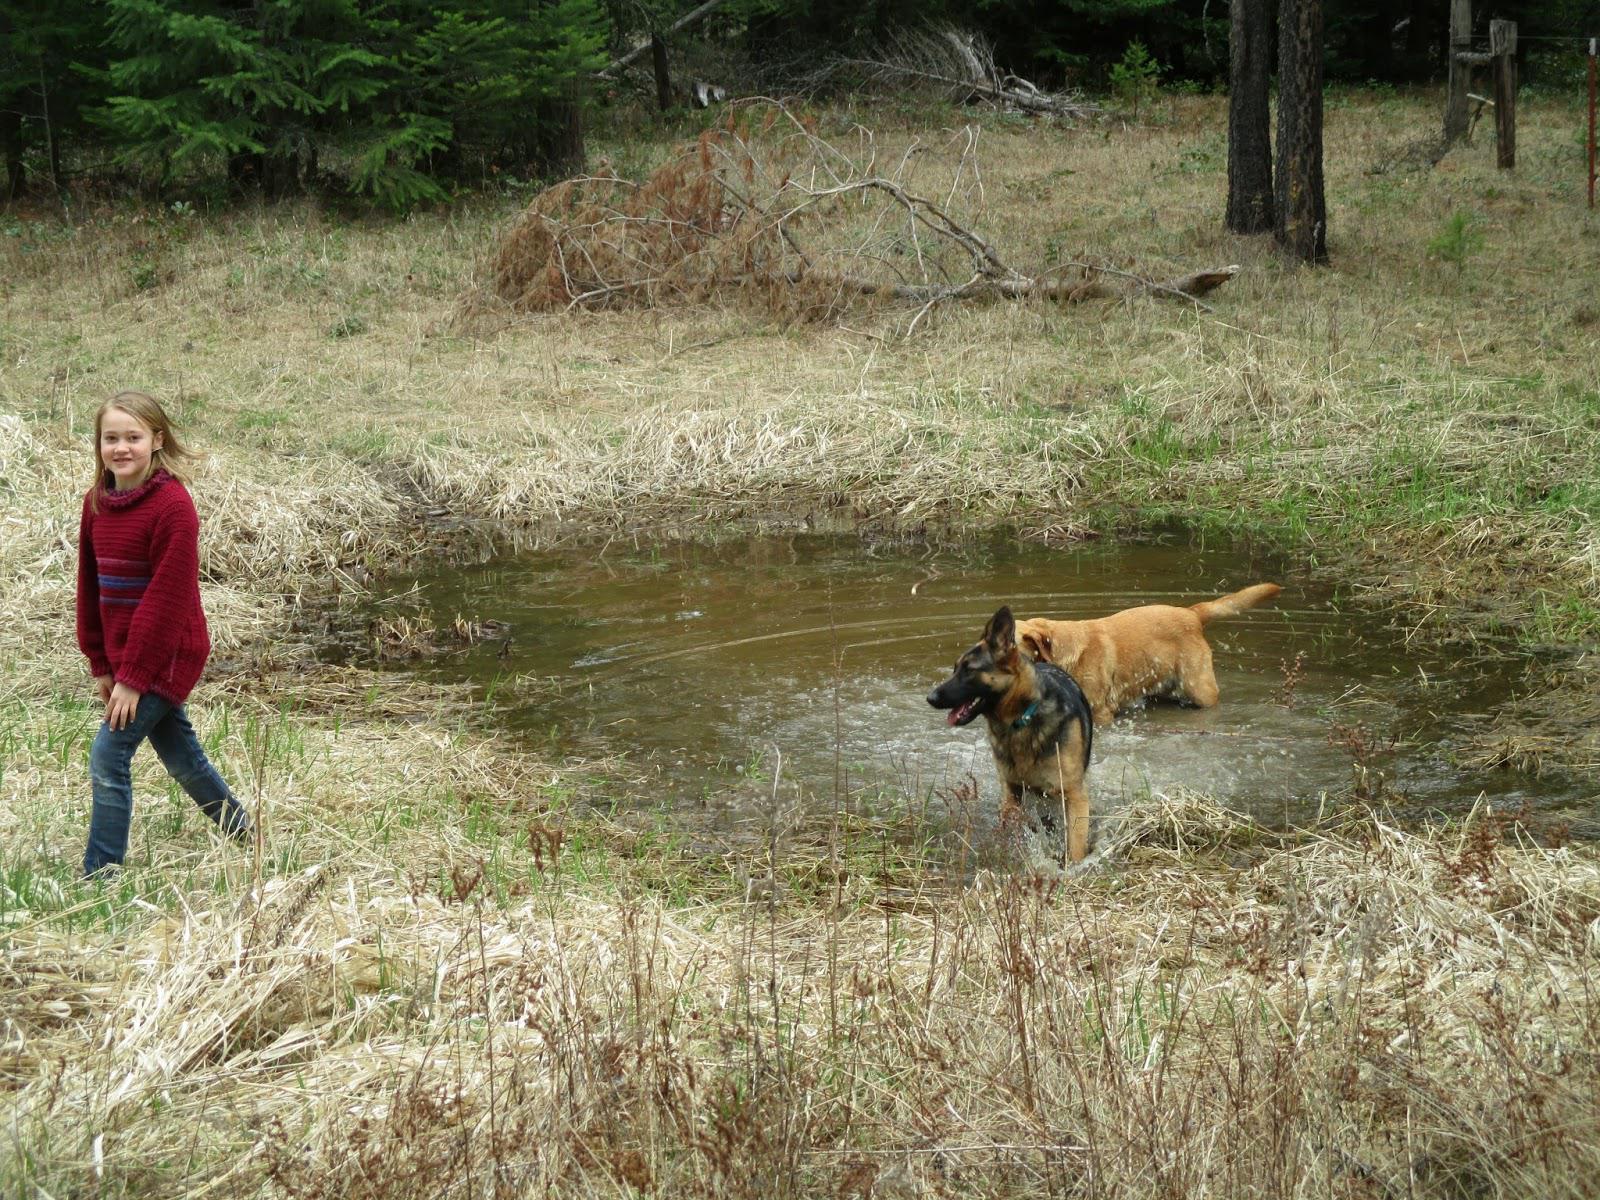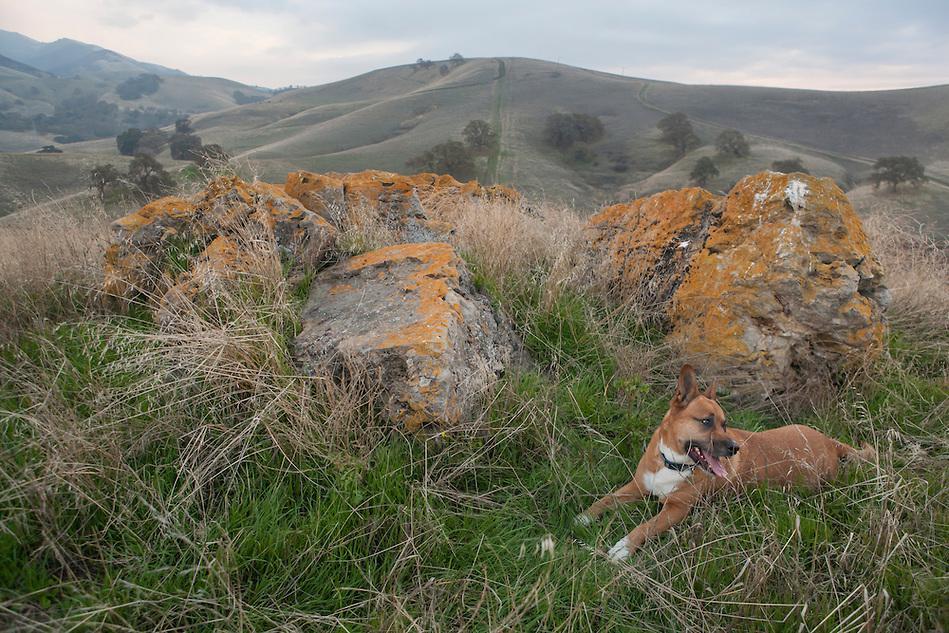The first image is the image on the left, the second image is the image on the right. For the images shown, is this caption "Each image includes one hound in a standing position, and the dog on the left is black-and-white with an open mouth and tail sticking out." true? Answer yes or no. No. The first image is the image on the left, the second image is the image on the right. Assess this claim about the two images: "There is the same number of dogs in both images.". Correct or not? Answer yes or no. No. 